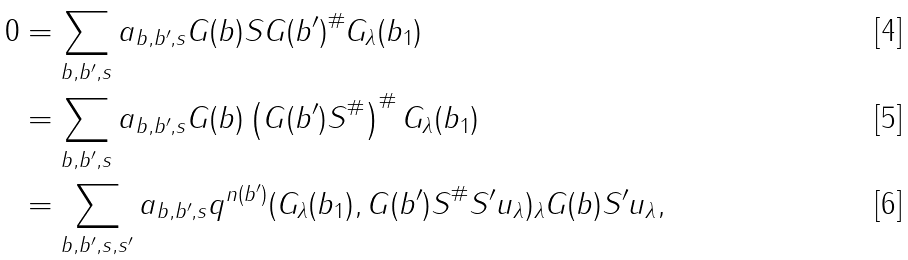<formula> <loc_0><loc_0><loc_500><loc_500>0 & = \sum _ { b , b ^ { \prime } , s } a _ { b , b ^ { \prime } , s } G ( b ) S G ( b ^ { \prime } ) ^ { \# } G _ { \lambda } ( b _ { 1 } ) \\ & = \sum _ { b , b ^ { \prime } , s } a _ { b , b ^ { \prime } , s } G ( b ) \left ( G ( b ^ { \prime } ) S ^ { \# } \right ) ^ { \# } G _ { \lambda } ( b _ { 1 } ) \\ & = \sum _ { b , b ^ { \prime } , s , s ^ { \prime } } a _ { b , b ^ { \prime } , s } q ^ { n ( b ^ { \prime } ) } ( G _ { \lambda } ( b _ { 1 } ) , G ( b ^ { \prime } ) S ^ { \# } S ^ { \prime } u _ { \lambda } ) _ { \lambda } G ( b ) S ^ { \prime } u _ { \lambda } ,</formula> 